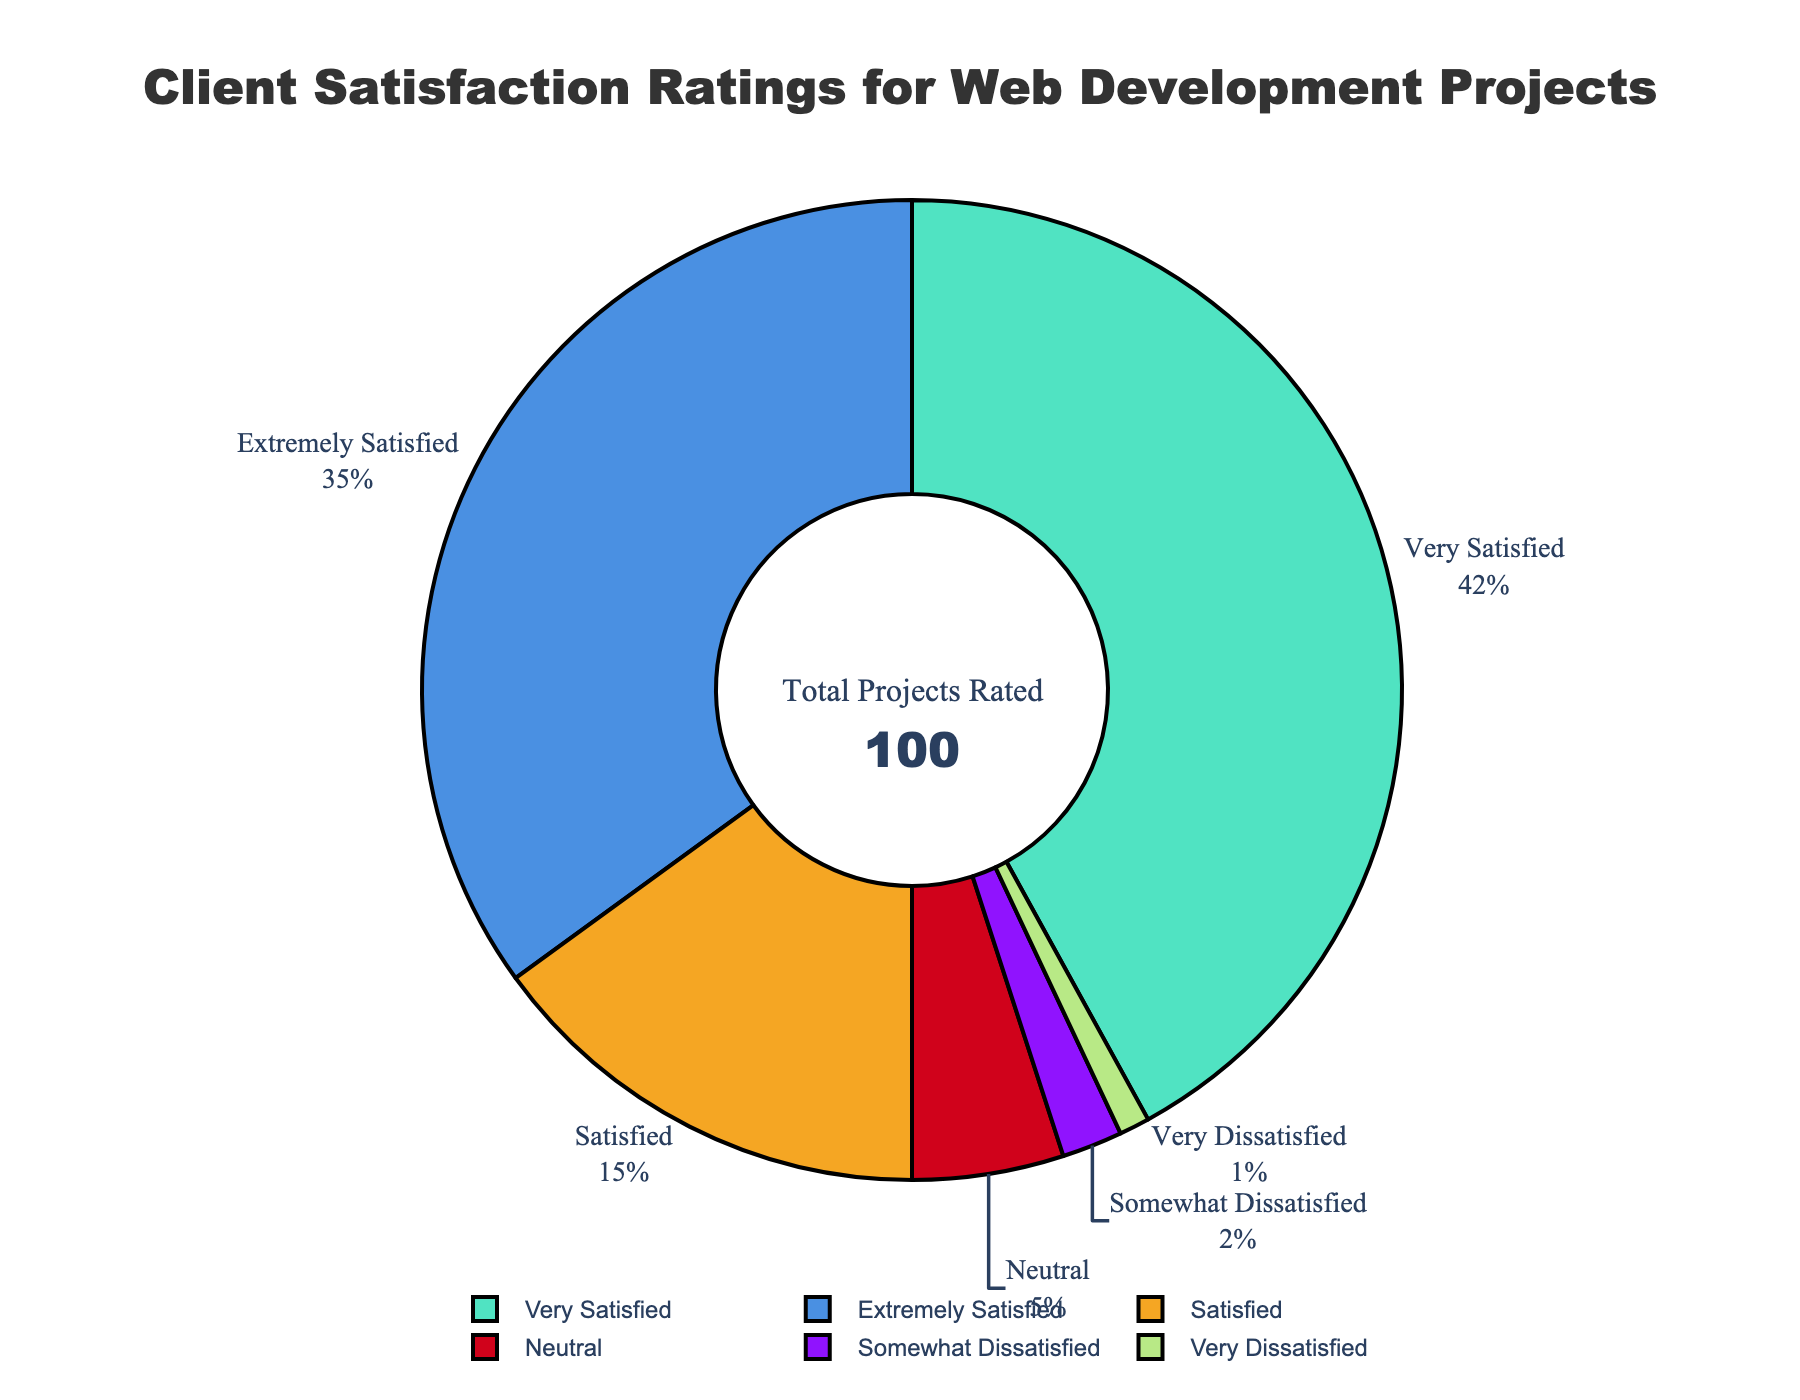Which rating category has the highest percentage? The pie chart shows that the "Very Satisfied" category has the highest percentage, labeled as 42%.
Answer: Very Satisfied What is the combined percentage of ratings that are "Satisfied" or better? Add the percentages of "Extremely Satisfied" (35%), "Very Satisfied" (42%), and "Satisfied" (15%): 35 + 42 + 15 = 92%.
Answer: 92% How much higher is the percentage of "Very Satisfied" ratings compared to the "Satisfied" ratings? Subtract the percentage of "Satisfied" (15%) from "Very Satisfied" (42%): 42 - 15 = 27%.
Answer: 27% Which rating category has the lowest percentage? The pie chart shows that the "Very Dissatisfied" category has the lowest percentage, labeled as 1%.
Answer: Very Dissatisfied What is the total percentage of ratings that are "Neutral" or worse? Add the percentages of "Neutral" (5%), "Somewhat Dissatisfied" (2%), and "Very Dissatisfied" (1%): 5 + 2 + 1 = 8%.
Answer: 8% How do the percentages of "Very Satisfied" and "Extremely Satisfied" ratings compare visually? The "Very Satisfied" section is larger than the "Extremely Satisfied" section, with "Very Satisfied" indicated at 42% and "Extremely Satisfied" at 35%.
Answer: "Very Satisfied" is larger What is the visual length relationship between the sections for "Neutral" and "Somewhat Dissatisfied" ratings? The "Neutral" section is visibly longer than the "Somewhat Dissatisfied" section, with "Neutral" at 5% and "Somewhat Dissatisfied" at 2%.
Answer: "Neutral" is longer How does the percentage of "Somewhat Dissatisfied" ratings compare to "Very Dissatisfied" ratings? The pie chart shows the "Somewhat Dissatisfied" ratings at 2%, which is higher than the "Very Dissatisfied" ratings at 1%.
Answer: "Somewhat Dissatisfied" is higher 